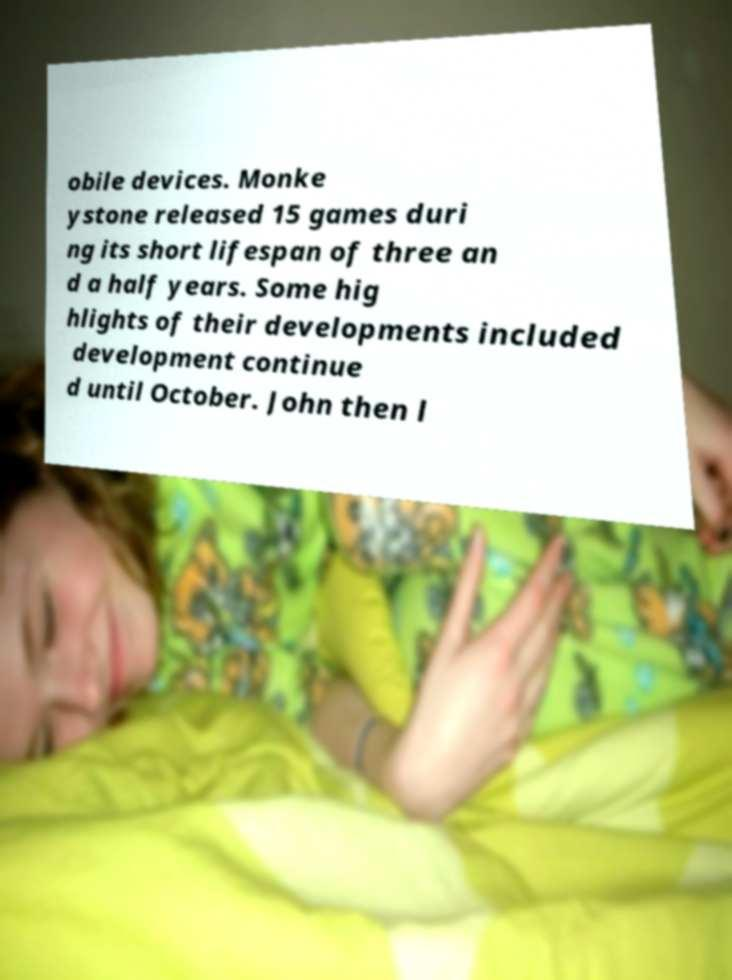Could you extract and type out the text from this image? obile devices. Monke ystone released 15 games duri ng its short lifespan of three an d a half years. Some hig hlights of their developments included development continue d until October. John then l 